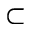Convert formula to latex. <formula><loc_0><loc_0><loc_500><loc_500>\subset</formula> 